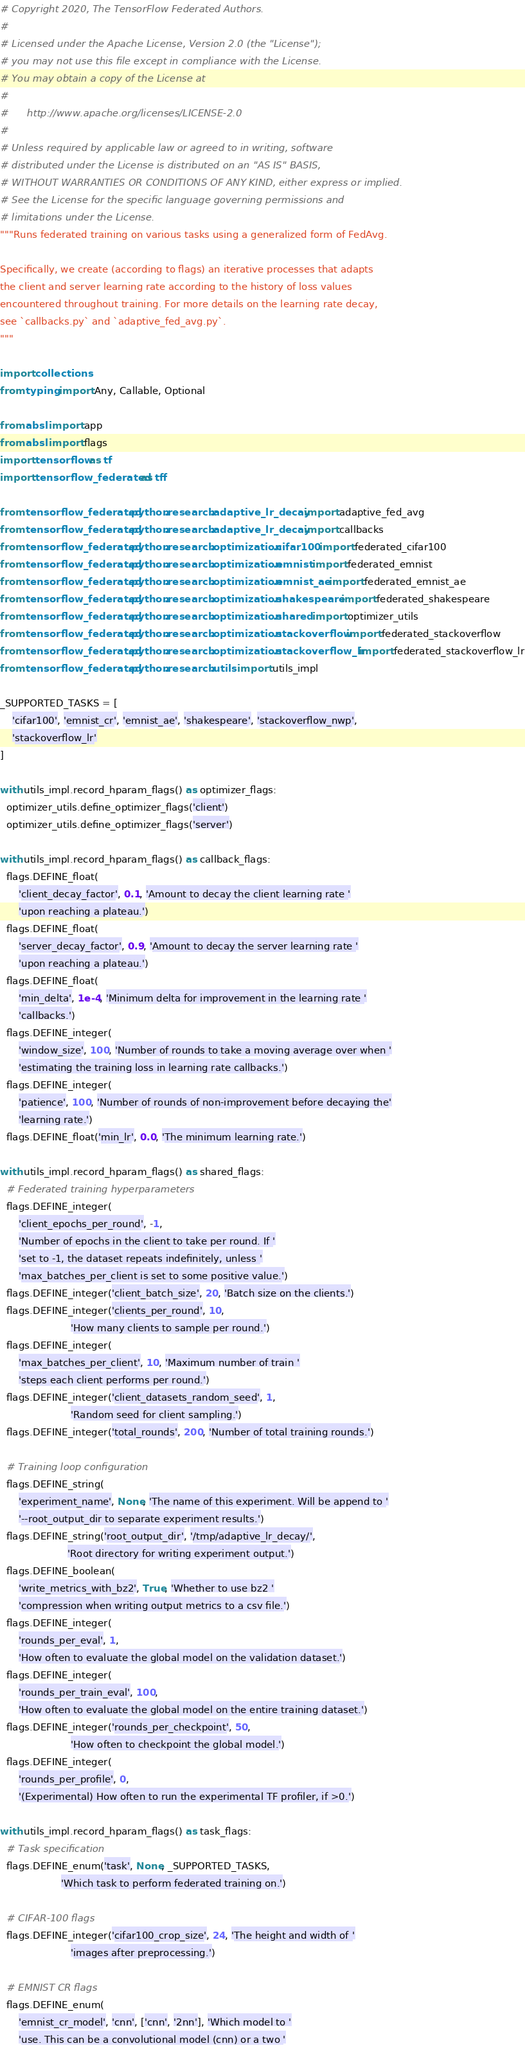Convert code to text. <code><loc_0><loc_0><loc_500><loc_500><_Python_># Copyright 2020, The TensorFlow Federated Authors.
#
# Licensed under the Apache License, Version 2.0 (the "License");
# you may not use this file except in compliance with the License.
# You may obtain a copy of the License at
#
#      http://www.apache.org/licenses/LICENSE-2.0
#
# Unless required by applicable law or agreed to in writing, software
# distributed under the License is distributed on an "AS IS" BASIS,
# WITHOUT WARRANTIES OR CONDITIONS OF ANY KIND, either express or implied.
# See the License for the specific language governing permissions and
# limitations under the License.
"""Runs federated training on various tasks using a generalized form of FedAvg.

Specifically, we create (according to flags) an iterative processes that adapts
the client and server learning rate according to the history of loss values
encountered throughout training. For more details on the learning rate decay,
see `callbacks.py` and `adaptive_fed_avg.py`.
"""

import collections
from typing import Any, Callable, Optional

from absl import app
from absl import flags
import tensorflow as tf
import tensorflow_federated as tff

from tensorflow_federated.python.research.adaptive_lr_decay import adaptive_fed_avg
from tensorflow_federated.python.research.adaptive_lr_decay import callbacks
from tensorflow_federated.python.research.optimization.cifar100 import federated_cifar100
from tensorflow_federated.python.research.optimization.emnist import federated_emnist
from tensorflow_federated.python.research.optimization.emnist_ae import federated_emnist_ae
from tensorflow_federated.python.research.optimization.shakespeare import federated_shakespeare
from tensorflow_federated.python.research.optimization.shared import optimizer_utils
from tensorflow_federated.python.research.optimization.stackoverflow import federated_stackoverflow
from tensorflow_federated.python.research.optimization.stackoverflow_lr import federated_stackoverflow_lr
from tensorflow_federated.python.research.utils import utils_impl

_SUPPORTED_TASKS = [
    'cifar100', 'emnist_cr', 'emnist_ae', 'shakespeare', 'stackoverflow_nwp',
    'stackoverflow_lr'
]

with utils_impl.record_hparam_flags() as optimizer_flags:
  optimizer_utils.define_optimizer_flags('client')
  optimizer_utils.define_optimizer_flags('server')

with utils_impl.record_hparam_flags() as callback_flags:
  flags.DEFINE_float(
      'client_decay_factor', 0.1, 'Amount to decay the client learning rate '
      'upon reaching a plateau.')
  flags.DEFINE_float(
      'server_decay_factor', 0.9, 'Amount to decay the server learning rate '
      'upon reaching a plateau.')
  flags.DEFINE_float(
      'min_delta', 1e-4, 'Minimum delta for improvement in the learning rate '
      'callbacks.')
  flags.DEFINE_integer(
      'window_size', 100, 'Number of rounds to take a moving average over when '
      'estimating the training loss in learning rate callbacks.')
  flags.DEFINE_integer(
      'patience', 100, 'Number of rounds of non-improvement before decaying the'
      'learning rate.')
  flags.DEFINE_float('min_lr', 0.0, 'The minimum learning rate.')

with utils_impl.record_hparam_flags() as shared_flags:
  # Federated training hyperparameters
  flags.DEFINE_integer(
      'client_epochs_per_round', -1,
      'Number of epochs in the client to take per round. If '
      'set to -1, the dataset repeats indefinitely, unless '
      'max_batches_per_client is set to some positive value.')
  flags.DEFINE_integer('client_batch_size', 20, 'Batch size on the clients.')
  flags.DEFINE_integer('clients_per_round', 10,
                       'How many clients to sample per round.')
  flags.DEFINE_integer(
      'max_batches_per_client', 10, 'Maximum number of train '
      'steps each client performs per round.')
  flags.DEFINE_integer('client_datasets_random_seed', 1,
                       'Random seed for client sampling.')
  flags.DEFINE_integer('total_rounds', 200, 'Number of total training rounds.')

  # Training loop configuration
  flags.DEFINE_string(
      'experiment_name', None, 'The name of this experiment. Will be append to '
      '--root_output_dir to separate experiment results.')
  flags.DEFINE_string('root_output_dir', '/tmp/adaptive_lr_decay/',
                      'Root directory for writing experiment output.')
  flags.DEFINE_boolean(
      'write_metrics_with_bz2', True, 'Whether to use bz2 '
      'compression when writing output metrics to a csv file.')
  flags.DEFINE_integer(
      'rounds_per_eval', 1,
      'How often to evaluate the global model on the validation dataset.')
  flags.DEFINE_integer(
      'rounds_per_train_eval', 100,
      'How often to evaluate the global model on the entire training dataset.')
  flags.DEFINE_integer('rounds_per_checkpoint', 50,
                       'How often to checkpoint the global model.')
  flags.DEFINE_integer(
      'rounds_per_profile', 0,
      '(Experimental) How often to run the experimental TF profiler, if >0.')

with utils_impl.record_hparam_flags() as task_flags:
  # Task specification
  flags.DEFINE_enum('task', None, _SUPPORTED_TASKS,
                    'Which task to perform federated training on.')

  # CIFAR-100 flags
  flags.DEFINE_integer('cifar100_crop_size', 24, 'The height and width of '
                       'images after preprocessing.')

  # EMNIST CR flags
  flags.DEFINE_enum(
      'emnist_cr_model', 'cnn', ['cnn', '2nn'], 'Which model to '
      'use. This can be a convolutional model (cnn) or a two '</code> 